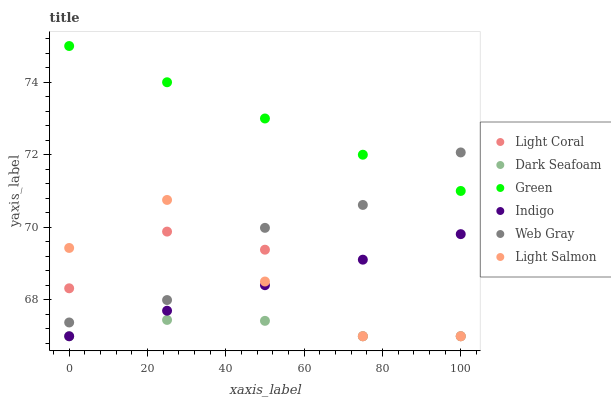Does Dark Seafoam have the minimum area under the curve?
Answer yes or no. Yes. Does Green have the maximum area under the curve?
Answer yes or no. Yes. Does Web Gray have the minimum area under the curve?
Answer yes or no. No. Does Web Gray have the maximum area under the curve?
Answer yes or no. No. Is Indigo the smoothest?
Answer yes or no. Yes. Is Light Coral the roughest?
Answer yes or no. Yes. Is Web Gray the smoothest?
Answer yes or no. No. Is Web Gray the roughest?
Answer yes or no. No. Does Light Salmon have the lowest value?
Answer yes or no. Yes. Does Web Gray have the lowest value?
Answer yes or no. No. Does Green have the highest value?
Answer yes or no. Yes. Does Web Gray have the highest value?
Answer yes or no. No. Is Indigo less than Green?
Answer yes or no. Yes. Is Green greater than Indigo?
Answer yes or no. Yes. Does Light Salmon intersect Indigo?
Answer yes or no. Yes. Is Light Salmon less than Indigo?
Answer yes or no. No. Is Light Salmon greater than Indigo?
Answer yes or no. No. Does Indigo intersect Green?
Answer yes or no. No. 